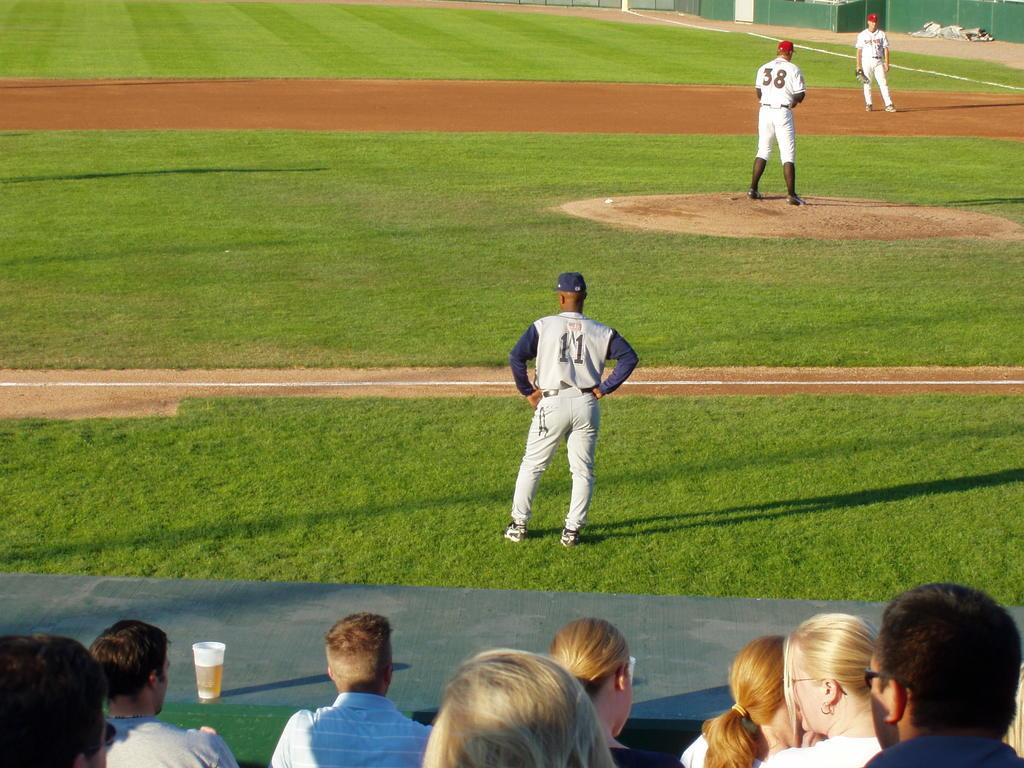Provide a one-sentence caption for the provided image. A third base coach wears the number 11 jersey as he watches the team play. 